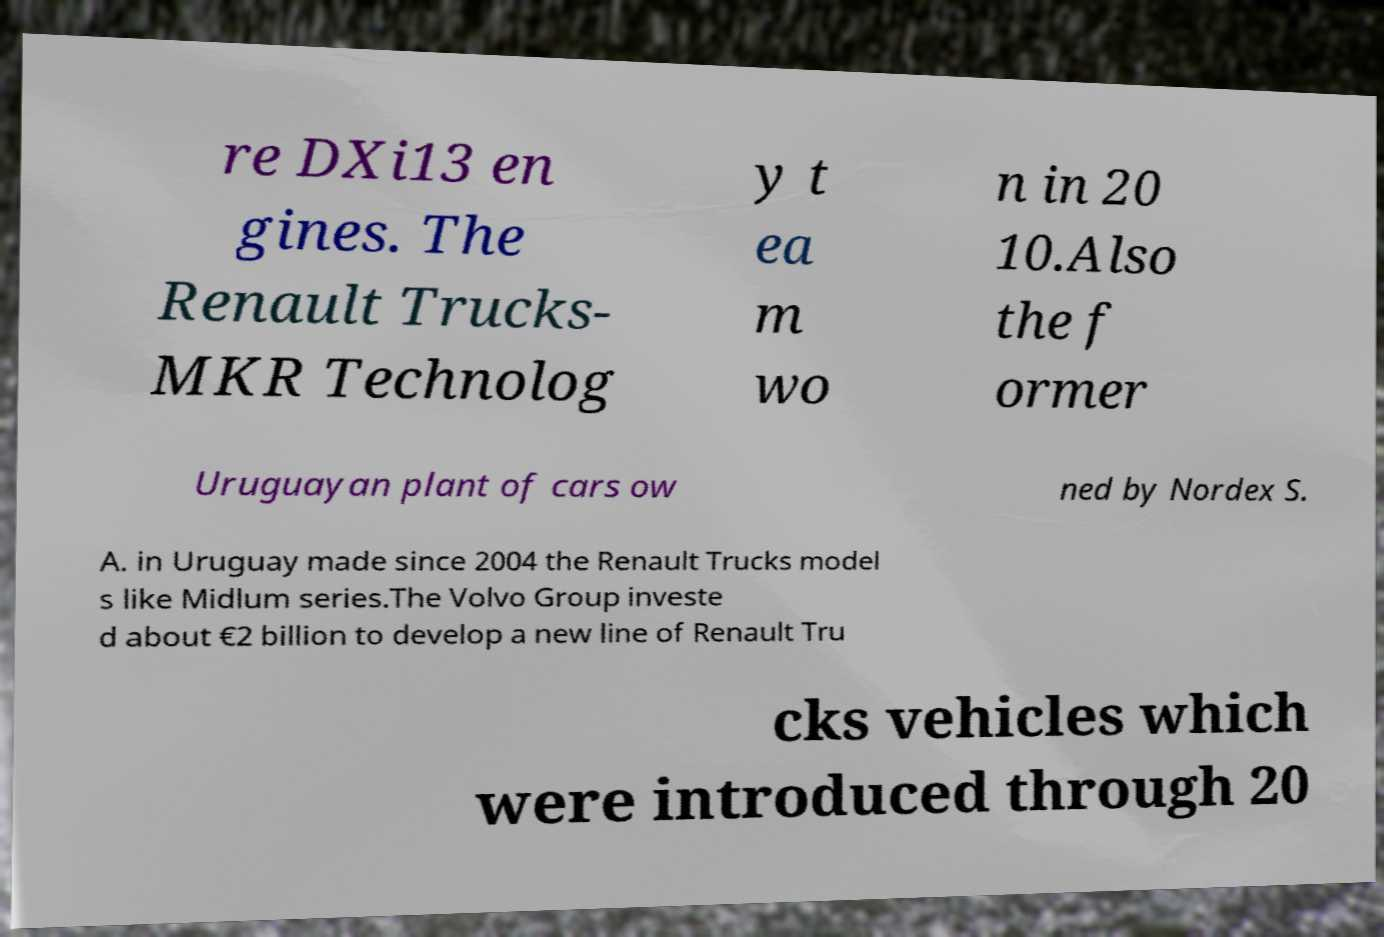Could you extract and type out the text from this image? re DXi13 en gines. The Renault Trucks- MKR Technolog y t ea m wo n in 20 10.Also the f ormer Uruguayan plant of cars ow ned by Nordex S. A. in Uruguay made since 2004 the Renault Trucks model s like Midlum series.The Volvo Group investe d about €2 billion to develop a new line of Renault Tru cks vehicles which were introduced through 20 